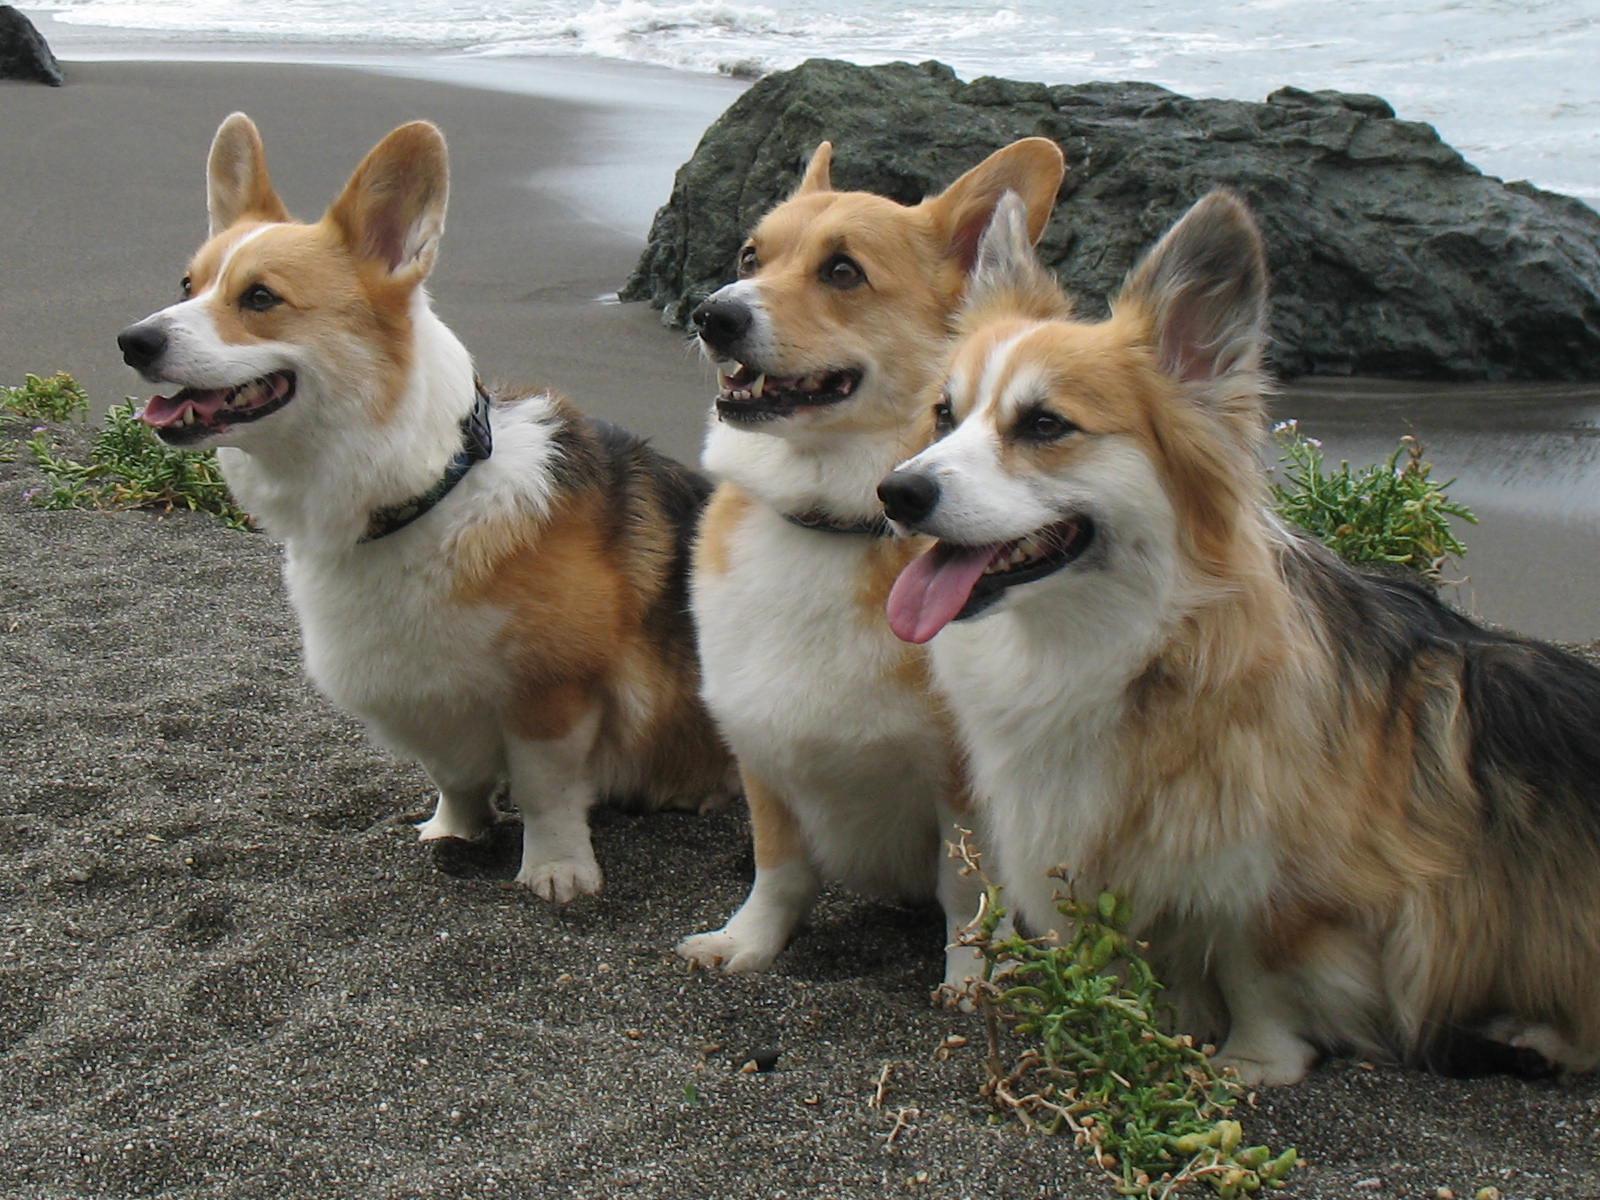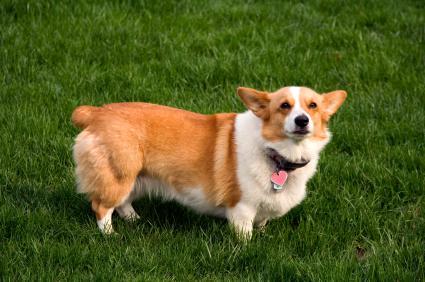The first image is the image on the left, the second image is the image on the right. Considering the images on both sides, is "An image shows exactly one short-legged dog, which is standing in the grass." valid? Answer yes or no. Yes. The first image is the image on the left, the second image is the image on the right. For the images displayed, is the sentence "At least one dog has its tongue sticking out of its mouth." factually correct? Answer yes or no. Yes. 